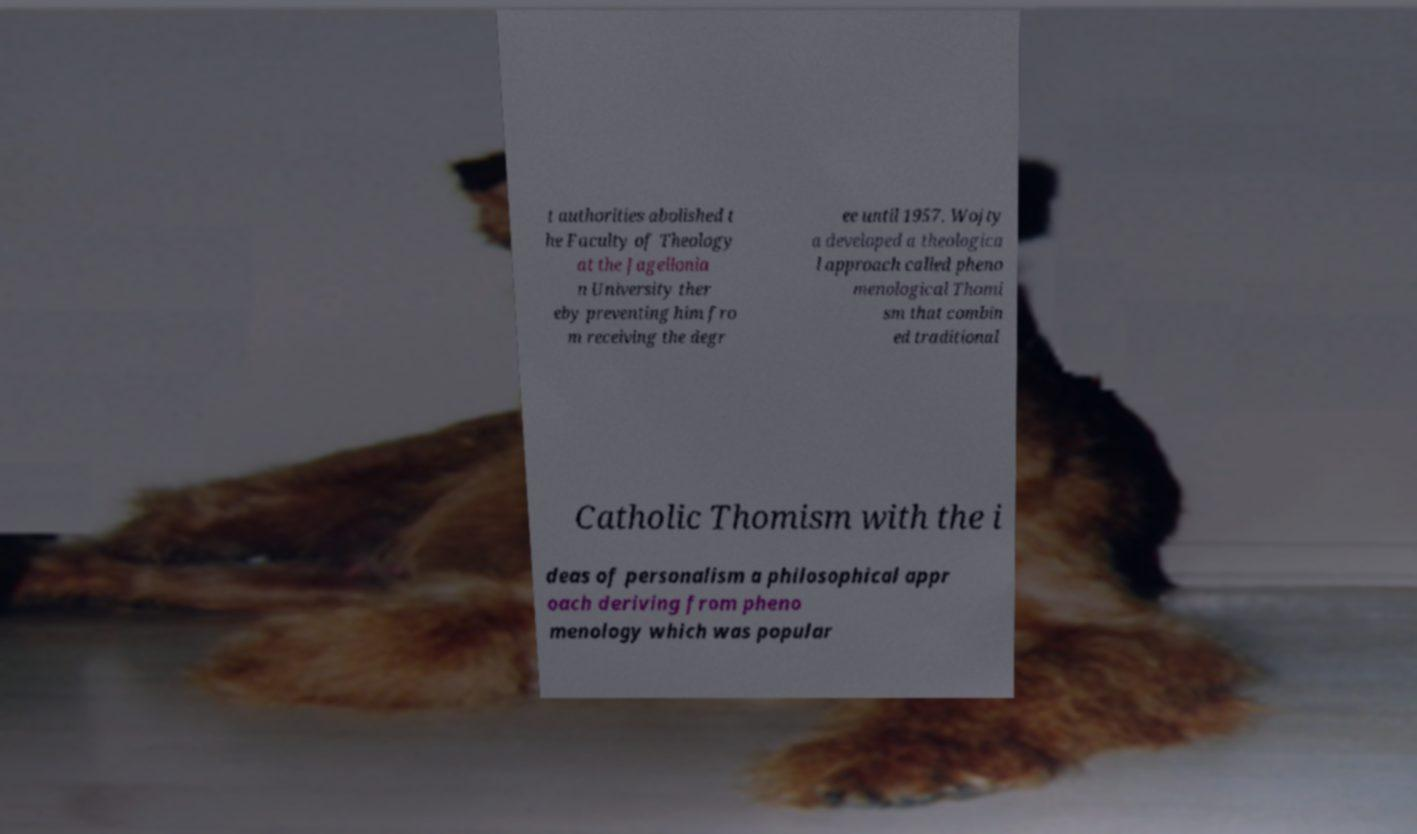I need the written content from this picture converted into text. Can you do that? t authorities abolished t he Faculty of Theology at the Jagellonia n University ther eby preventing him fro m receiving the degr ee until 1957. Wojty a developed a theologica l approach called pheno menological Thomi sm that combin ed traditional Catholic Thomism with the i deas of personalism a philosophical appr oach deriving from pheno menology which was popular 